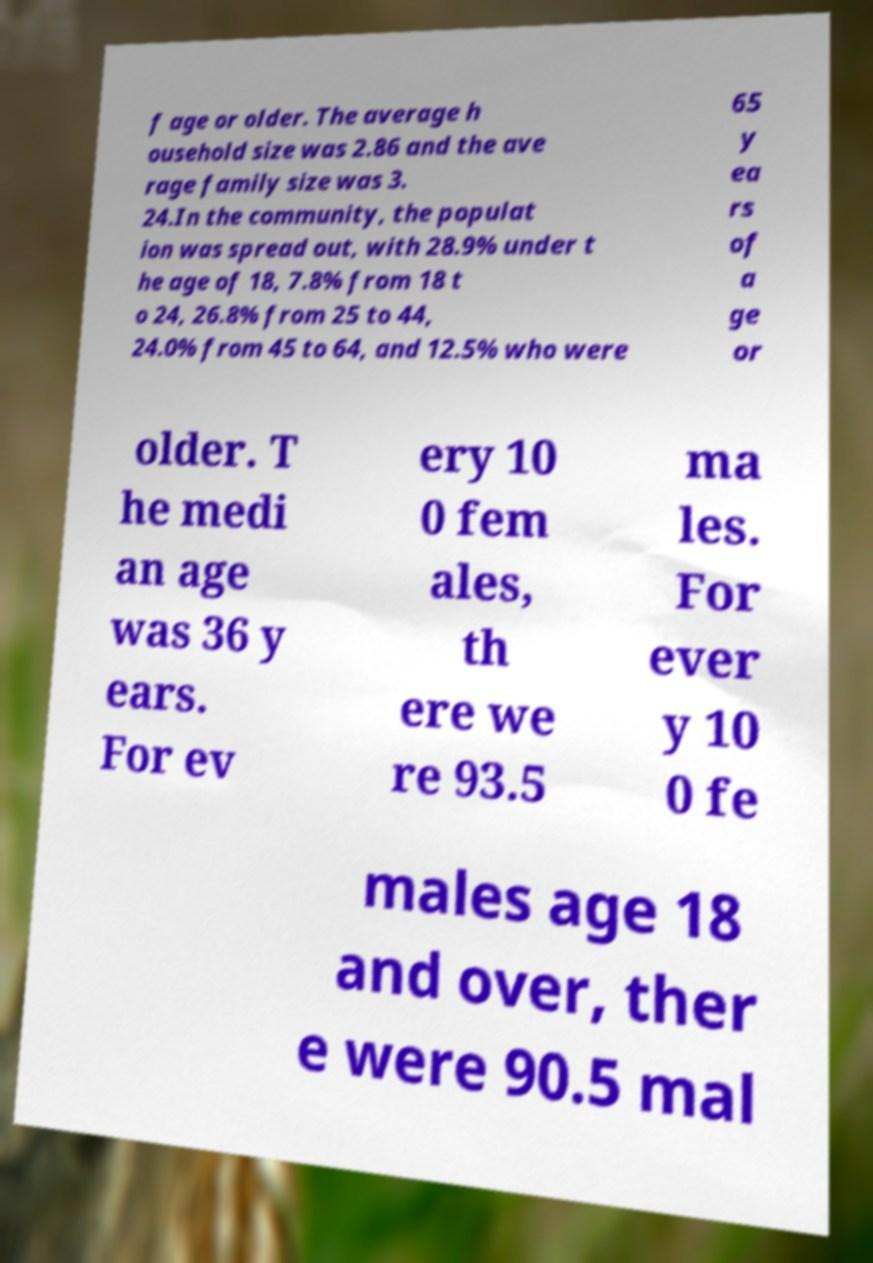Can you accurately transcribe the text from the provided image for me? f age or older. The average h ousehold size was 2.86 and the ave rage family size was 3. 24.In the community, the populat ion was spread out, with 28.9% under t he age of 18, 7.8% from 18 t o 24, 26.8% from 25 to 44, 24.0% from 45 to 64, and 12.5% who were 65 y ea rs of a ge or older. T he medi an age was 36 y ears. For ev ery 10 0 fem ales, th ere we re 93.5 ma les. For ever y 10 0 fe males age 18 and over, ther e were 90.5 mal 